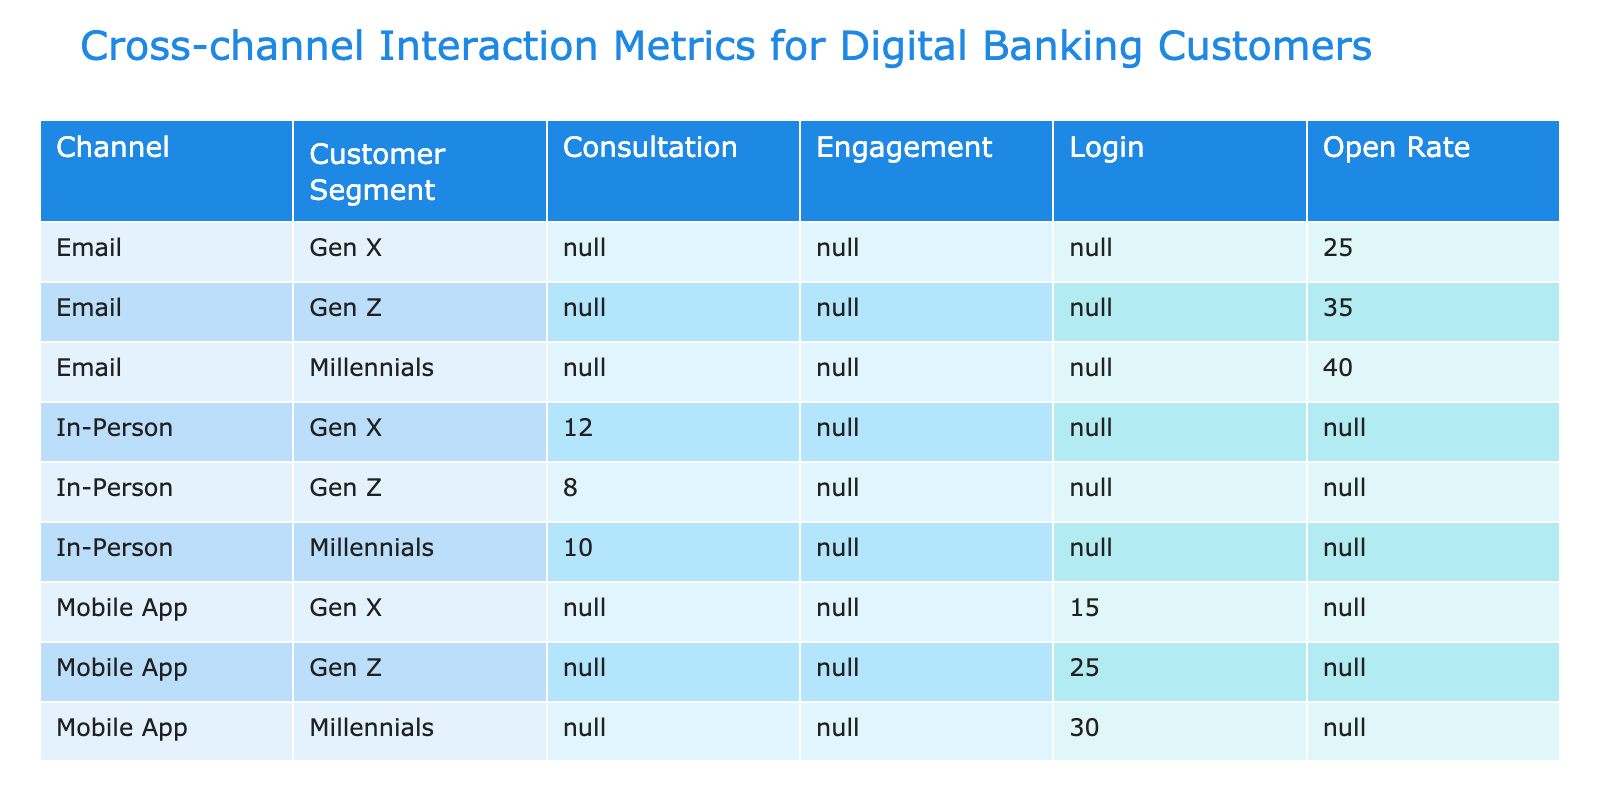What is the total interaction frequency for Millennials across all channels? To find the total interaction frequency for Millennials, we will sum the interaction frequencies for the 'Millennials' segment across each channel: Mobile App (30) + Web Portal (20) + Social Media (50) + Email (40) + In-Person (10) = 150.
Answer: 150 Which channel has the highest customer satisfaction score among Gen Z? Looking at the Gen Z row for each channel, the customer satisfaction scores are: Mobile App (4.3), Web Portal (4.2), Social Media (4.6), Email (4.3), and In-Person (4.4). The Social Media channel has the highest score of 4.6.
Answer: Social Media Is the total number of consultations greater in the In-Person channel compared to the Social Media channel? The total interaction frequency for consultations is only available in the In-Person channel, which has a frequency of 10. The Social Media channel does not have consultations listed (0). Hence, 10 > 0 is true.
Answer: Yes What is the average transaction value for Gen X customers across all interaction types? To find the average transaction value for Gen X, we will consider the values from all their interactions: Login (200), Engagement (20), Open Rate (50), and Consultation (210). First, we find the total: 200 + 20 + 50 + 210 = 480. Then we divide by the number of interactions (4): 480 / 4 = 120.
Answer: 120 Which customer segment engages the most through Social Media? For Social Media, the engagement numbers are as follows: Millennials (50), Gen Z (60), and Gen X (30). The segment with the highest engagement is Gen Z with a frequency of 60.
Answer: Gen Z Is the average transaction value for Millennials higher than that for Gen X? The average transaction value for Millennials is calculated as follows: Total transactions = 150 + 30 + 75 + 200 = 455 and Average = 455 / 4 = 113.75. For Gen X, Total = 200 + 20 + 50 + 210 = 480 and Average = 480 / 4 = 120. Since 113.75 < 120, the statement is false.
Answer: No What is the total interaction frequency for the Web Portal channel? Summing the interaction frequencies for the Web Portal: Login (12) + Engagement (0) + Open Rate (0) + Consultation (0) = 12.
Answer: 12 How does the engagement frequency of Millennials in Social Media compare to that of Gen X in the same channel? The engagement frequency for Millennials in Social Media is 50, while for Gen X it is 30. Since 50 > 30, we can conclude that Millennials engage more than Gen X on Social Media.
Answer: Millennials engage more 